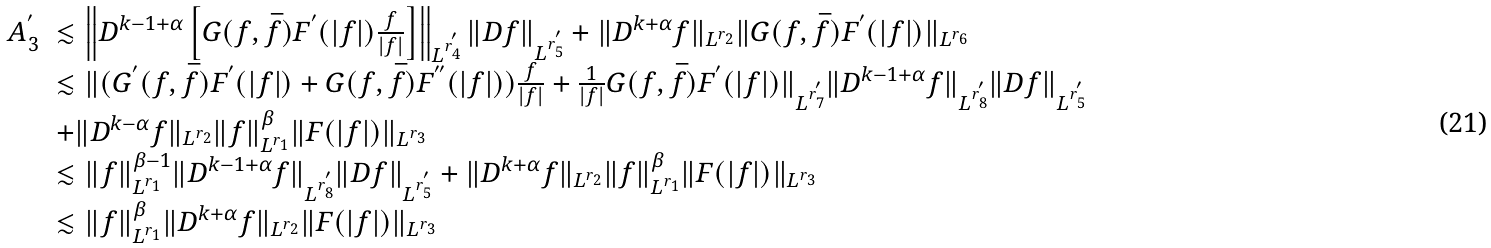Convert formula to latex. <formula><loc_0><loc_0><loc_500><loc_500>\begin{array} { l l } A ^ { ^ { \prime } } _ { 3 } & \lesssim \left \| D ^ { k - 1 + \alpha } \left [ G ( f , \bar { f } ) F ^ { ^ { \prime } } ( | f | ) \frac { f } { | f | } \right ] \right \| _ { L ^ { r ^ { ^ { \prime } } _ { 4 } } } \| D f \| _ { L ^ { r ^ { ^ { \prime } } _ { 5 } } } + \| D ^ { k + \alpha } f \| _ { L ^ { r _ { 2 } } } \| G ( f , \bar { f } ) F ^ { ^ { \prime } } ( | f | ) \| _ { L ^ { r _ { 6 } } } \\ & \lesssim \| ( G ^ { ^ { \prime } } ( f , \bar { f } ) F ^ { ^ { \prime } } ( | f | ) + G ( f , \bar { f } ) F ^ { ^ { \prime \prime } } ( | f | ) ) \frac { f } { | f | } + \frac { 1 } { | f | } G ( f , \bar { f } ) F ^ { ^ { \prime } } ( | f | ) \| _ { L ^ { r ^ { ^ { \prime } } _ { 7 } } } \| D ^ { k - 1 + \alpha } f \| _ { L ^ { r ^ { ^ { \prime } } _ { 8 } } } \| D f \| _ { L ^ { r ^ { ^ { \prime } } _ { 5 } } } \\ & + \| D ^ { k - \alpha } f \| _ { L ^ { r _ { 2 } } } \| f \| ^ { \beta } _ { L ^ { r _ { 1 } } } \| F ( | f | ) \| _ { L ^ { r _ { 3 } } } \\ & \lesssim \| f \| ^ { \beta - 1 } _ { L ^ { r _ { 1 } } } \| D ^ { k - 1 + \alpha } f \| _ { L ^ { r _ { 8 } ^ { ^ { \prime } } } } \| D f \| _ { L ^ { r _ { 5 } ^ { ^ { \prime } } } } + \| D ^ { k + \alpha } f \| _ { L ^ { r _ { 2 } } } \| f \| ^ { \beta } _ { L ^ { r _ { 1 } } } \| F ( | f | ) \| _ { L ^ { r _ { 3 } } } \\ & \lesssim \| f \| ^ { \beta } _ { L ^ { r _ { 1 } } } \| D ^ { k + \alpha } f \| _ { L ^ { r _ { 2 } } } \| F ( | f | ) \| _ { L ^ { r _ { 3 } } } \end{array}</formula> 